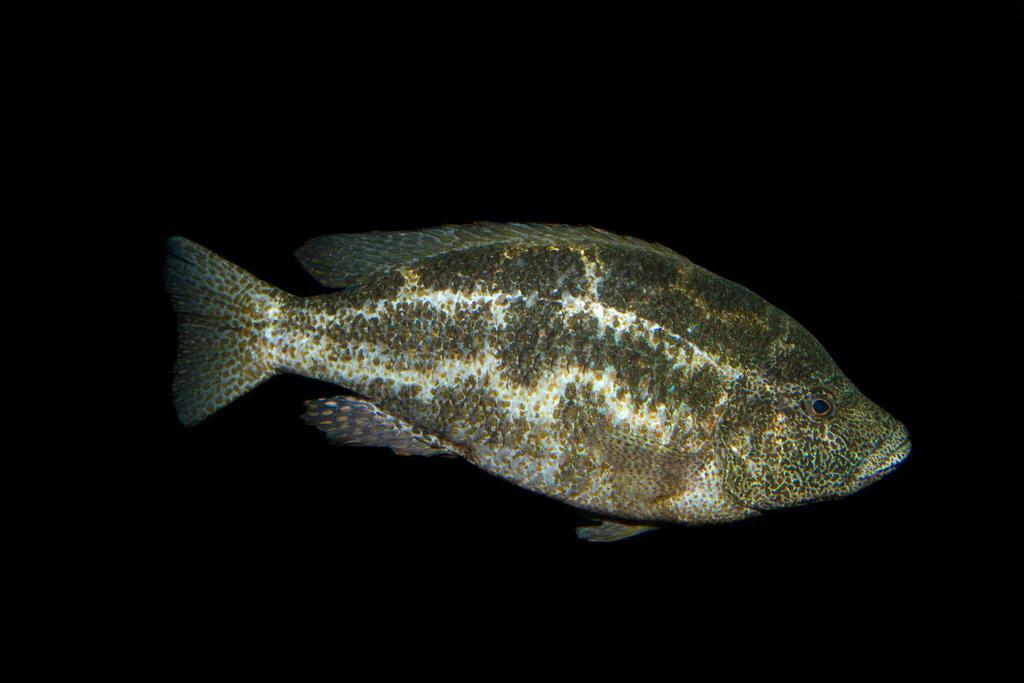Please provide a concise description of this image. In this image there is a fish, in the background it is black. 